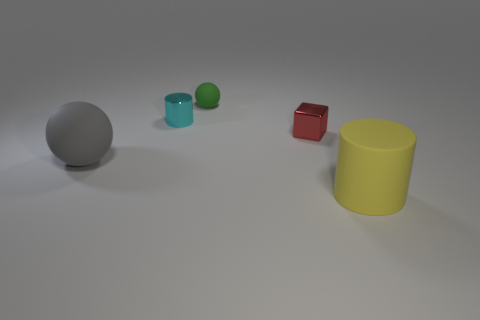How might the relative sizes and positions of the objects contribute to a discussion on perspective in visual art? The arrangement of objects in the image, with varying sizes and at differing distances from the viewer's standpoint, can be used to illustrate the concept of perspective. In visual arts, perspective is the technique used to represent three-dimensional objects on a two-dimensional plane as they appear to the human eye. For instance, the larger grey sphere, being closer to the camera, emphasizes how objects appear bigger the closer they are to the viewer, while the smaller cube and spheres further back appear to diminish in size, simulating depth. Additionally, the alignment of objects can guide the viewer's eye through the image, a technique often employed by artists to lead attention or create a sense of movement. 